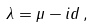<formula> <loc_0><loc_0><loc_500><loc_500>\lambda = \mu - i d \, ,</formula> 